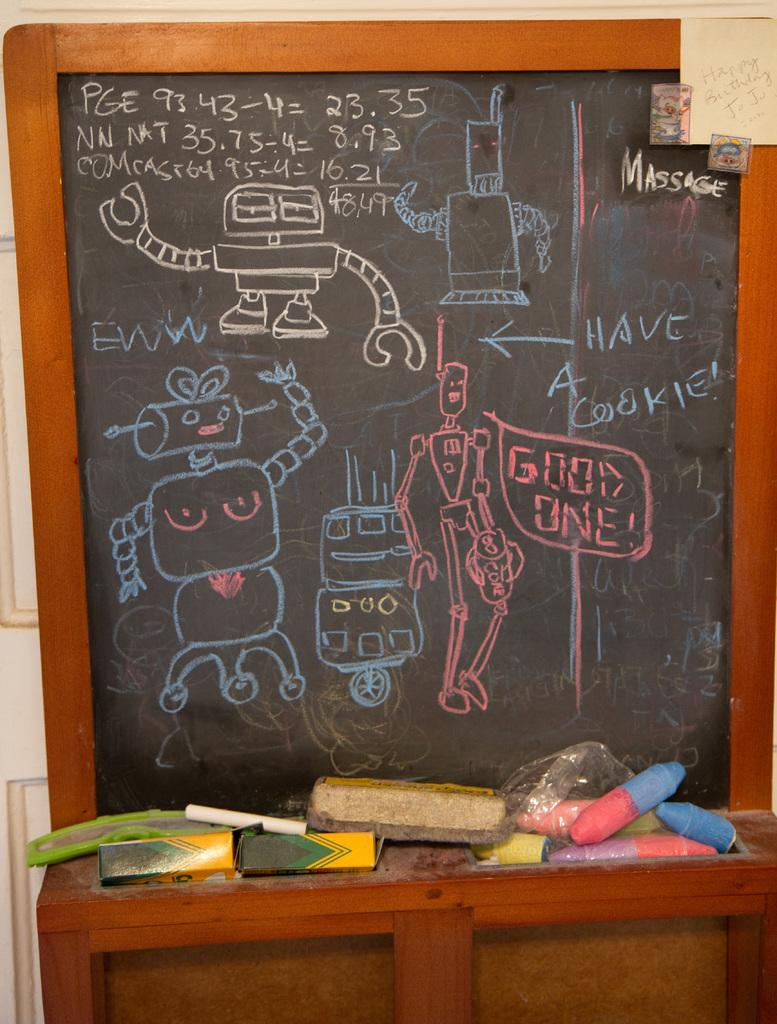Provide a one-sentence caption for the provided image. A chalk board full of robot drawings portrays a robot saying "Good One!". 